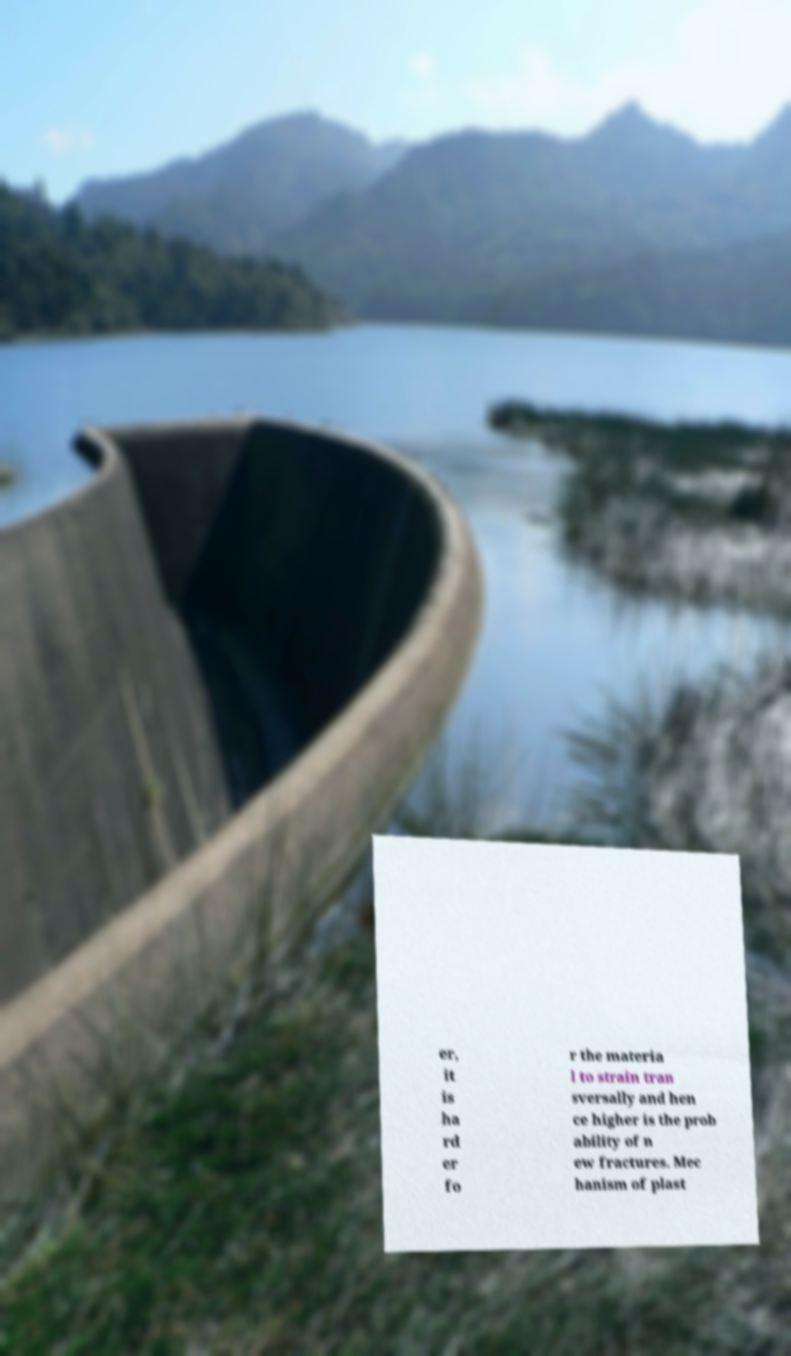Please identify and transcribe the text found in this image. er, it is ha rd er fo r the materia l to strain tran sversally and hen ce higher is the prob ability of n ew fractures. Mec hanism of plast 